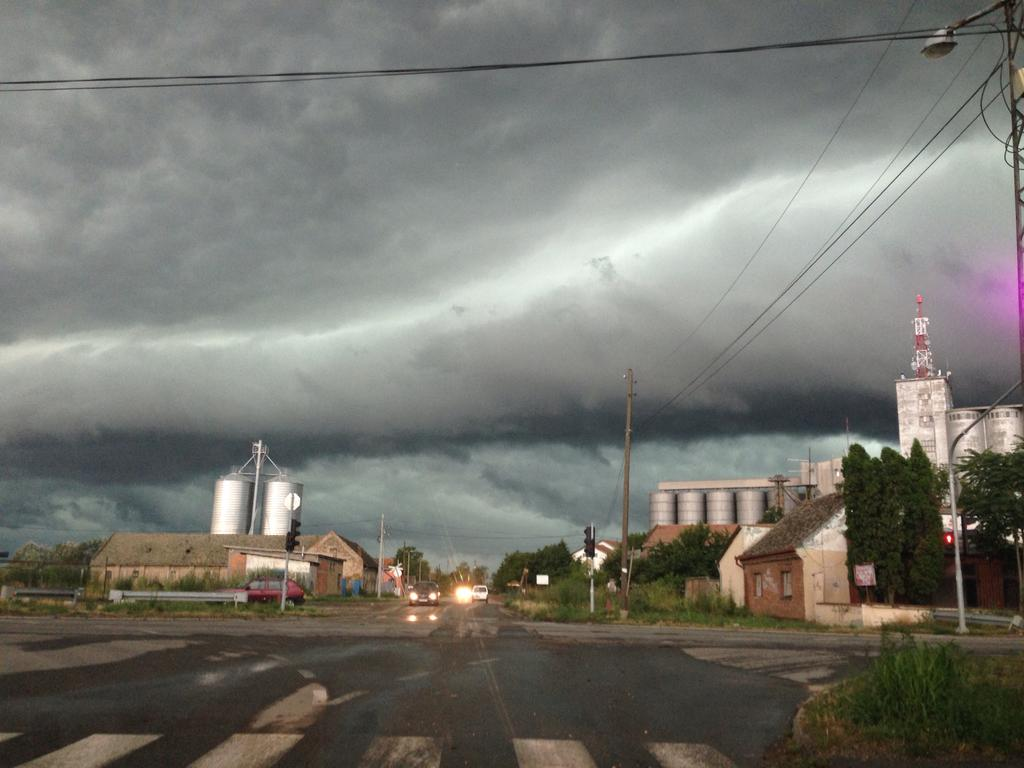What can be seen on the road in the image? There are vehicles on the road in the image. What type of vegetation is visible in the image? Grass and trees are present in the image. What type of structures can be seen in the image? There are houses with windows in the image. What else is present in the image besides the houses? Poles, wires, containers, and grass are visible in the image. What is visible in the background of the image? The sky is visible in the background of the image, with clouds present. What type of toothpaste is being used by the trees in the image? There is no toothpaste present in the image, as trees do not use toothpaste. How can you tell if the image is quiet or not? The image is a still photograph and does not convey sound, so it cannot be determined if it is quiet or not. 